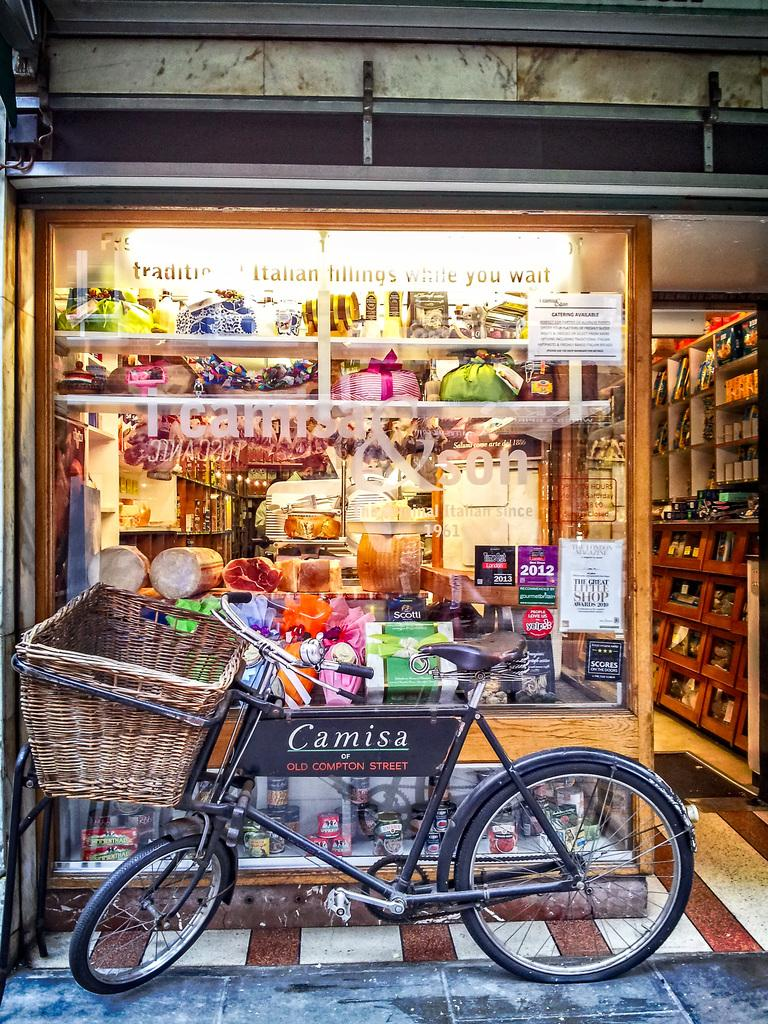<image>
Offer a succinct explanation of the picture presented. A bicycle parked in front of a food chest on Camisa of Old Compton 